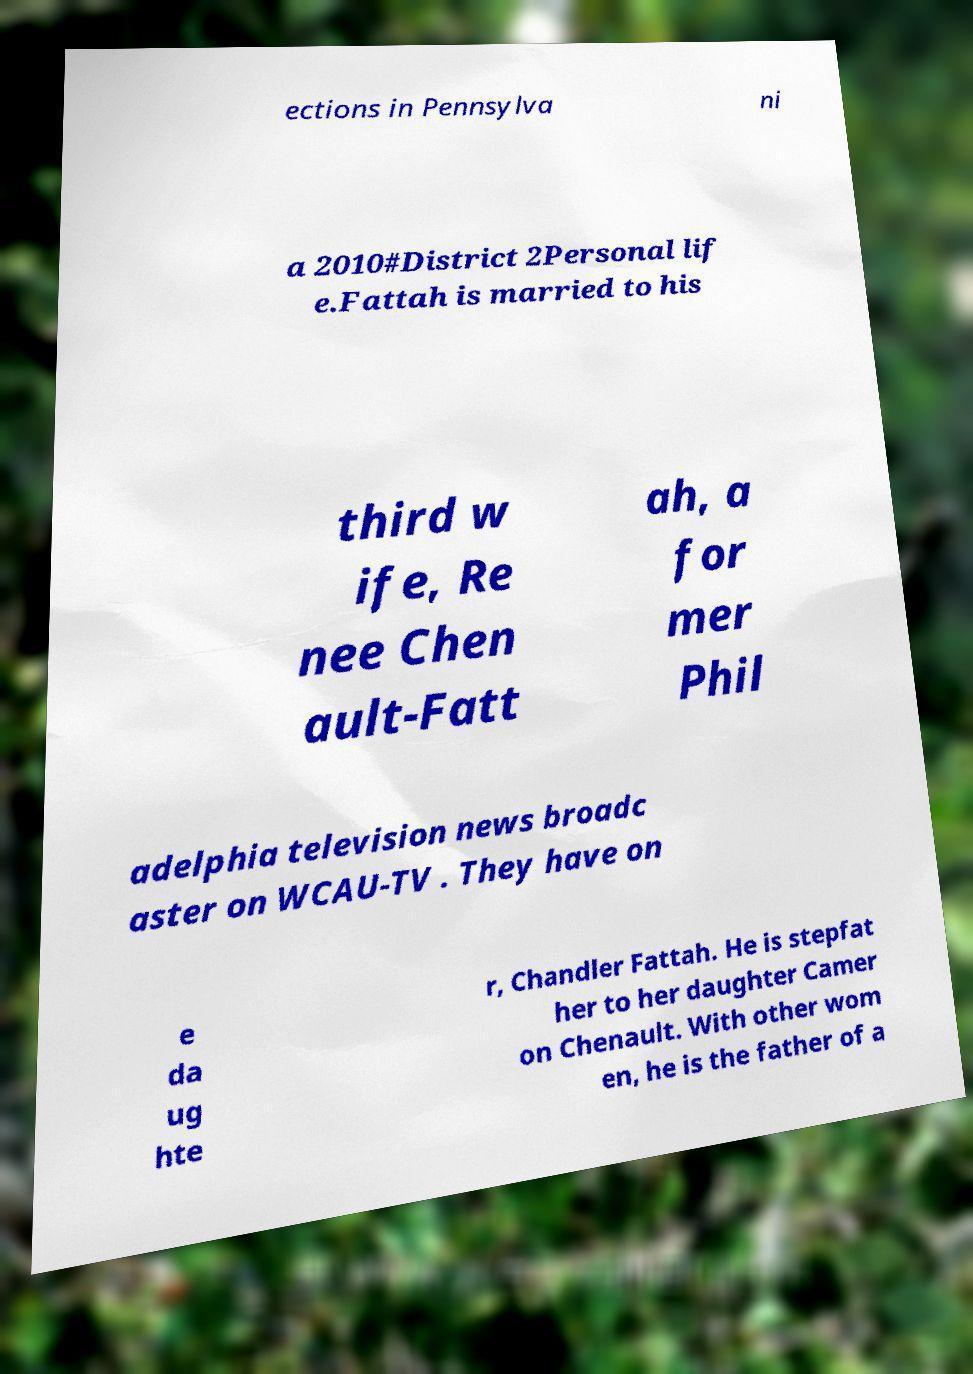Could you assist in decoding the text presented in this image and type it out clearly? ections in Pennsylva ni a 2010#District 2Personal lif e.Fattah is married to his third w ife, Re nee Chen ault-Fatt ah, a for mer Phil adelphia television news broadc aster on WCAU-TV . They have on e da ug hte r, Chandler Fattah. He is stepfat her to her daughter Camer on Chenault. With other wom en, he is the father of a 